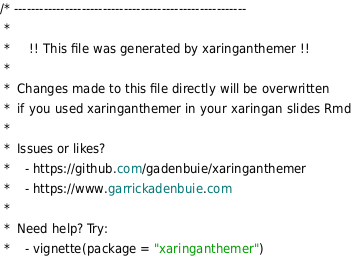Convert code to text. <code><loc_0><loc_0><loc_500><loc_500><_CSS_>/* -------------------------------------------------------
 *
 *     !! This file was generated by xaringanthemer !!
 *
 *  Changes made to this file directly will be overwritten
 *  if you used xaringanthemer in your xaringan slides Rmd
 *
 *  Issues or likes?
 *    - https://github.com/gadenbuie/xaringanthemer
 *    - https://www.garrickadenbuie.com
 *
 *  Need help? Try:
 *    - vignette(package = "xaringanthemer")</code> 